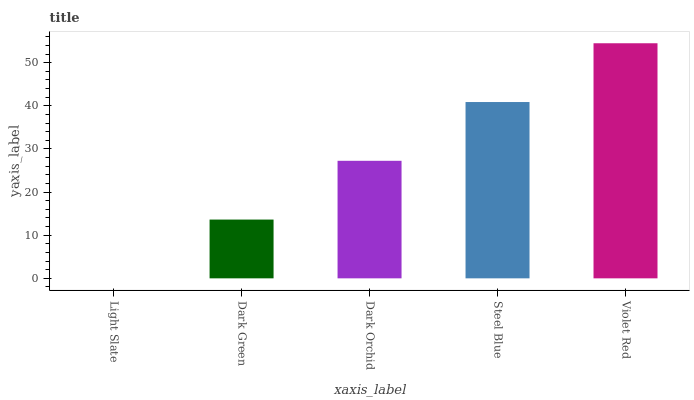Is Light Slate the minimum?
Answer yes or no. Yes. Is Violet Red the maximum?
Answer yes or no. Yes. Is Dark Green the minimum?
Answer yes or no. No. Is Dark Green the maximum?
Answer yes or no. No. Is Dark Green greater than Light Slate?
Answer yes or no. Yes. Is Light Slate less than Dark Green?
Answer yes or no. Yes. Is Light Slate greater than Dark Green?
Answer yes or no. No. Is Dark Green less than Light Slate?
Answer yes or no. No. Is Dark Orchid the high median?
Answer yes or no. Yes. Is Dark Orchid the low median?
Answer yes or no. Yes. Is Light Slate the high median?
Answer yes or no. No. Is Dark Green the low median?
Answer yes or no. No. 